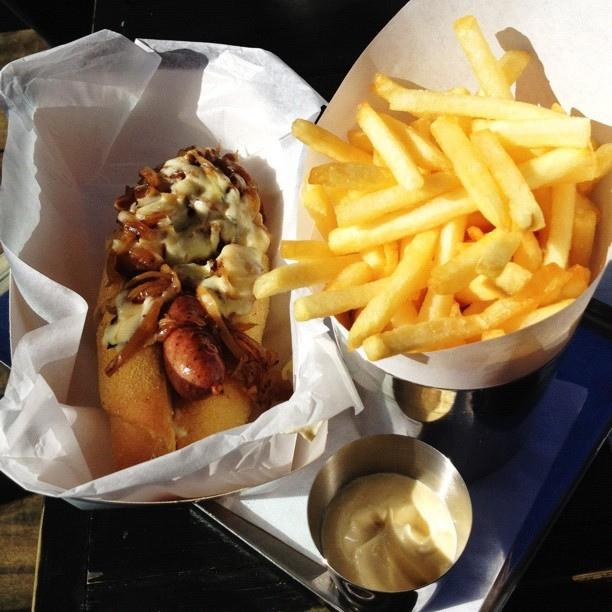Is there a dipping sauce?
Answer briefly. Yes. Are the French fries burnt?
Keep it brief. No. Are any of these foods made from potatoes?
Quick response, please. Yes. 